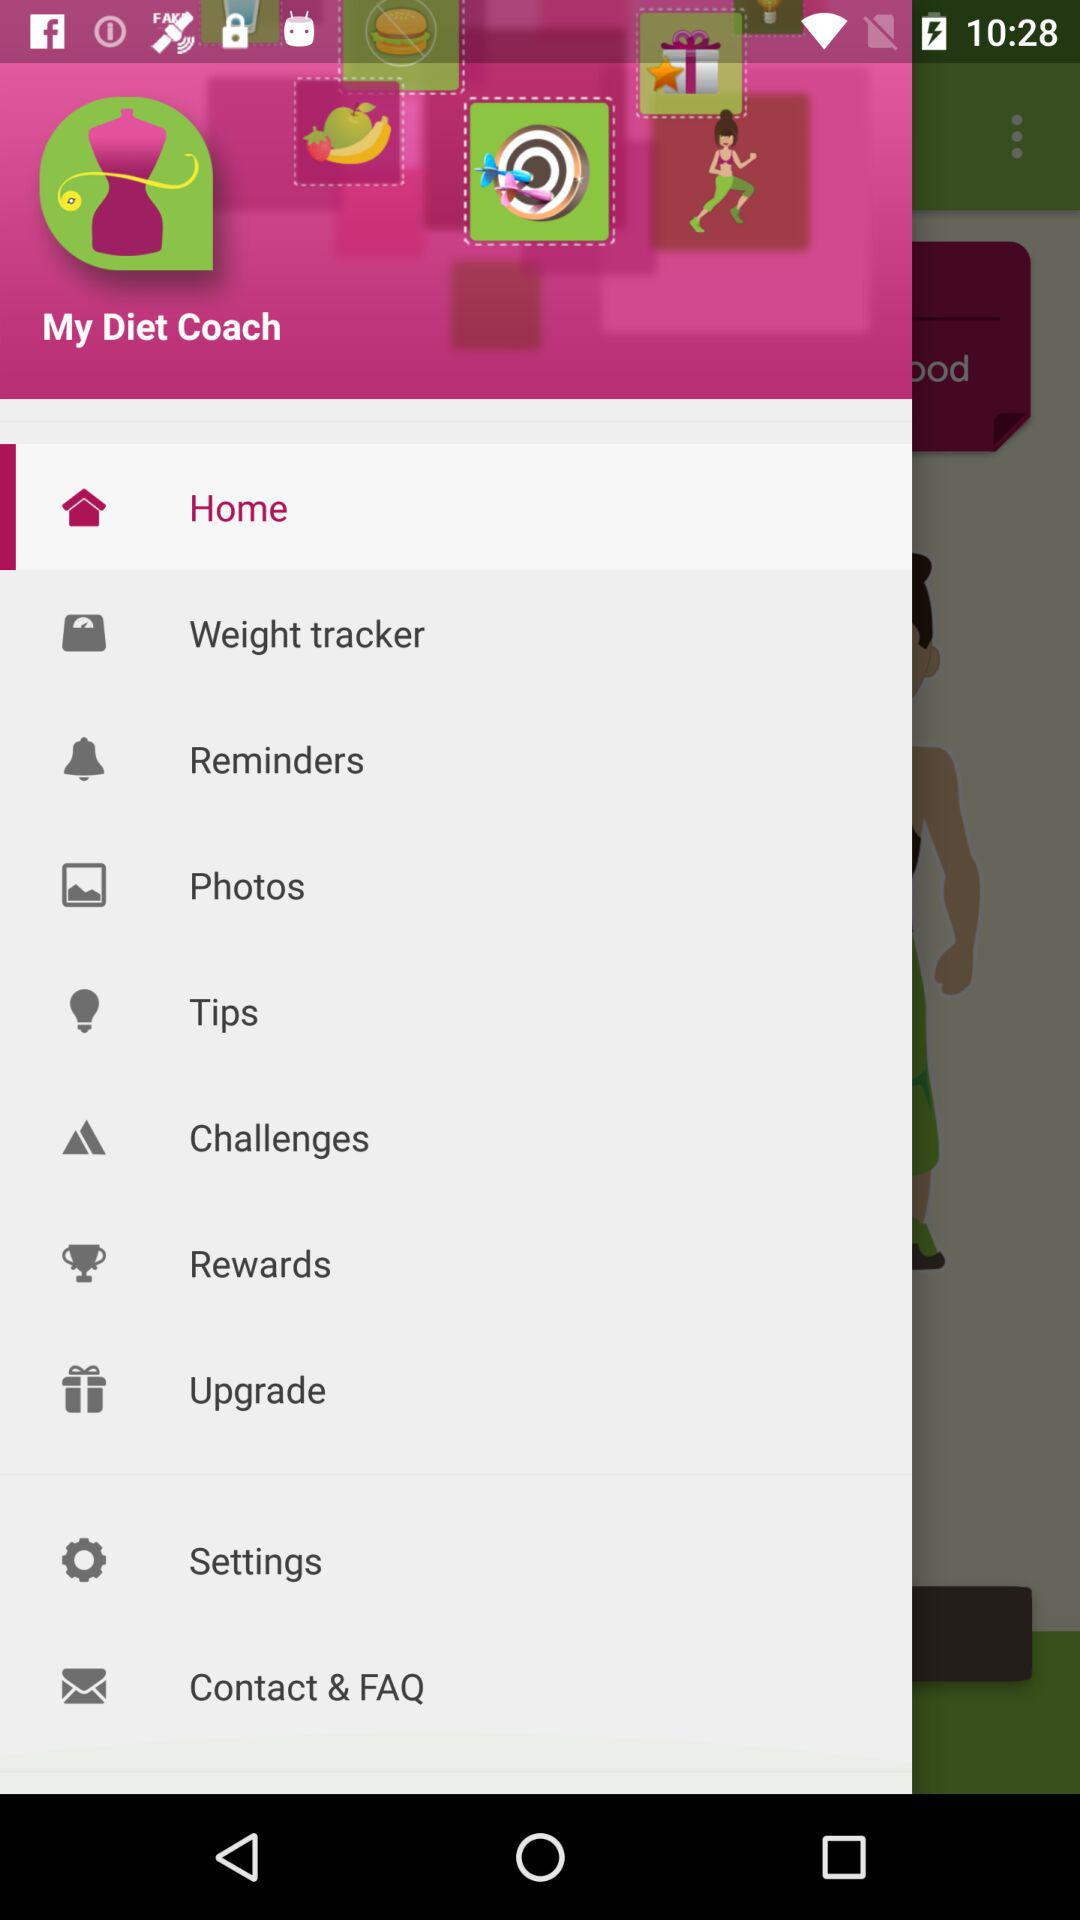Which option is selected? The selected option is "Home". 